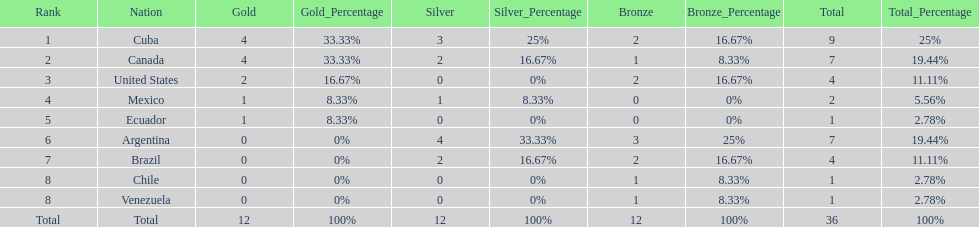Which nation won gold but did not win silver? United States. 